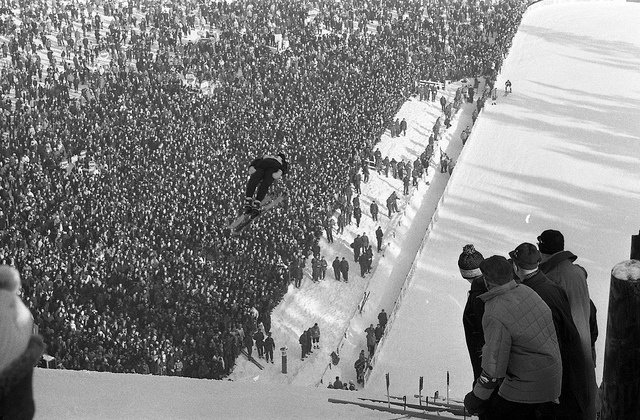Describe the objects in this image and their specific colors. I can see people in darkgray, gray, black, and lightgray tones, people in darkgray, black, gray, and lightgray tones, people in darkgray, black, gray, and lightgray tones, people in darkgray, black, gray, and lightgray tones, and people in darkgray, black, gray, and lightgray tones in this image. 